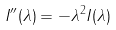Convert formula to latex. <formula><loc_0><loc_0><loc_500><loc_500>I ^ { \prime \prime } ( \lambda ) = - \lambda ^ { 2 } I ( \lambda )</formula> 